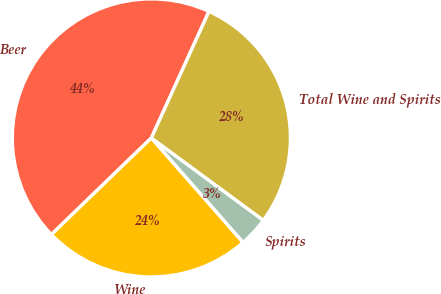Convert chart. <chart><loc_0><loc_0><loc_500><loc_500><pie_chart><fcel>Beer<fcel>Wine<fcel>Spirits<fcel>Total Wine and Spirits<nl><fcel>44.03%<fcel>24.24%<fcel>3.44%<fcel>28.29%<nl></chart> 